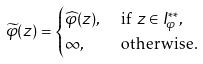Convert formula to latex. <formula><loc_0><loc_0><loc_500><loc_500>\widetilde { \varphi } ( z ) & = \begin{cases} \widehat { \varphi } ( z ) , & \text { if $z\in I_{\varphi}^{**}$} , \\ \infty , & \text { otherwise.} \\ \end{cases}</formula> 